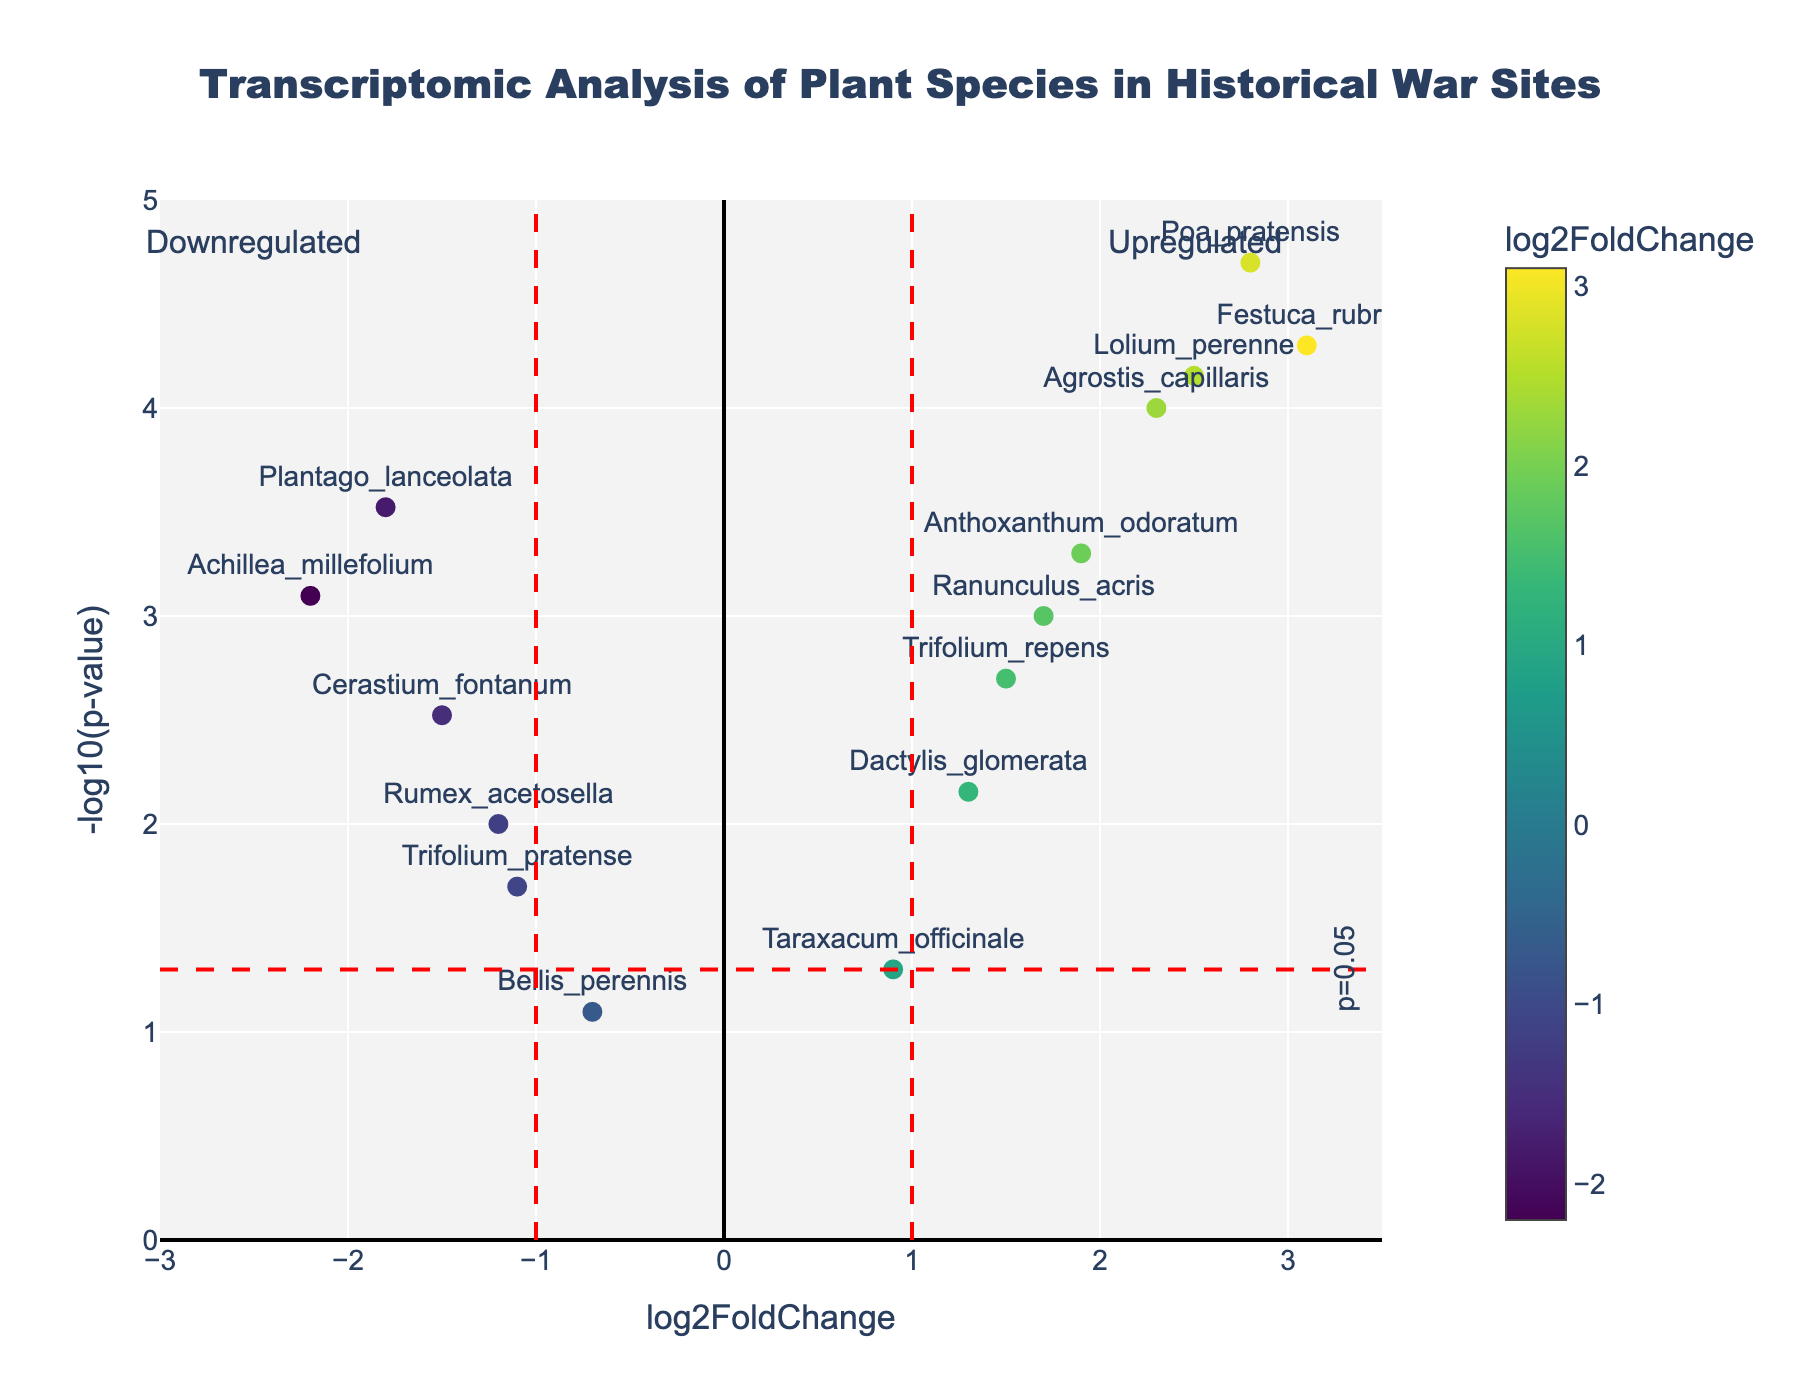what is the title of the volcano plot? The title of the plot is located at the top of the figure. It reads "Transcriptomic Analysis of Plant Species in Historical War Sites."
Answer: Transcriptomic Analysis of Plant Species in Historical War Sites How many genes show significant downregulation (log2FoldChange < -1 and p-value < 0.05)? Significant downregulation is indicated by points to the left of the vertical line at log2FoldChange = -1 and above the horizontal line at p-value = 0.05 (-log10(p-value) > 1.3). The points that meet these criteria are 'Plantago_lanceolata', 'Achillea_millefolium', and 'Cerastium_fontanum'.
Answer: 3 Which gene exhibits the highest upregulation? The highest upregulation corresponds to the point furthest to the right. 'Festuca_rubra' with a log2FoldChange of 3.1 is the furthest to the right.
Answer: Festuca_rubra How many genes have a log2FoldChange greater than 1? Genes with log2FoldChange > 1 are located to the right of the vertical line at log2FoldChange = 1. By counting them, we get 'Agrostis_capillaris', 'Trifolium_repens', 'Festuca_rubra', 'Ranunculus_acris', 'Poa_pratensis', 'Anthoxanthum_odoratum', and 'Lolium_perenne', 'Dactylis_glomerata'.
Answer: 8 Which gene(s) show a p-value close to 0.05 threshold? Genes with a p-value close to 0.05 will be near the horizontal line at -log10(0.05) = 1.3. 'Taraxacum_officinale' with a p-value of 0.05 is closest to that line.
Answer: Taraxacum_officinale What is the relationship between log2FoldChange and p-value for 'Poa_pratensis'? To find this, refer to the y and x coordinates of 'Poa_pratensis' in the plot. Its log2FoldChange is 2.8, and the p-value is represented as a point above the horizontal threshold, i.e., p-value < 0.05.
Answer: log2FoldChange = 2.8, p-value < 0.05 Comparing 'Agrostis_capillaris' and 'Lolium_perenne', which gene has a lower p-value? A lower p-value corresponds to a higher -log10(p-value). 'Agrostis_capillaris' has a higher -log10(p-value) than 'Lolium_perenne', so it has a lower p-value.
Answer: Agrostis_capillaris Which genes have log2FoldChange between -2 and 2 but are not significant (p-value > 0.05)? These genes lie within -2 < log2FoldChange < 2 and below the p-value threshold line (-log10(p-value) < 1.3). 'Bellis_perennis' meets these criteria.
Answer: Bellis_perennis 